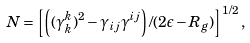Convert formula to latex. <formula><loc_0><loc_0><loc_500><loc_500>N = \left [ \left ( ( \gamma ^ { k } _ { k } ) ^ { 2 } - \gamma _ { i j } \gamma ^ { i j } \right ) / ( 2 \epsilon - R _ { g } ) \right ] ^ { 1 / 2 } ,</formula> 